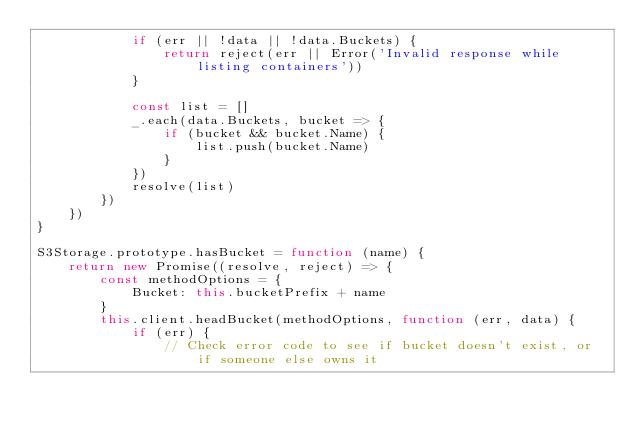Convert code to text. <code><loc_0><loc_0><loc_500><loc_500><_JavaScript_>            if (err || !data || !data.Buckets) {
                return reject(err || Error('Invalid response while listing containers'))
            }

            const list = []
            _.each(data.Buckets, bucket => {
                if (bucket && bucket.Name) {
                    list.push(bucket.Name)
                }
            })
            resolve(list)
        })
    })
}

S3Storage.prototype.hasBucket = function (name) {
    return new Promise((resolve, reject) => {
        const methodOptions = {
            Bucket: this.bucketPrefix + name
        }
        this.client.headBucket(methodOptions, function (err, data) {
            if (err) {
                // Check error code to see if bucket doesn't exist, or if someone else owns it</code> 